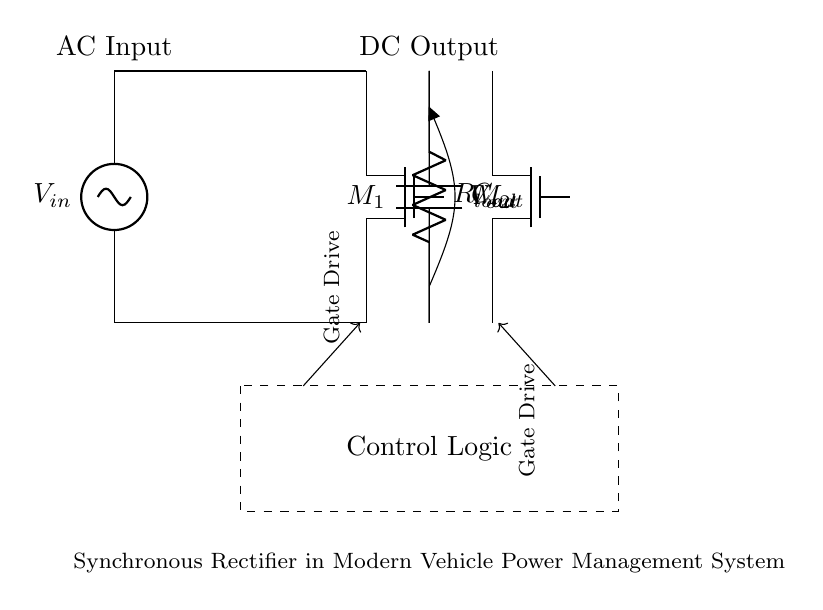What type of rectifier is shown in the circuit? The circuit employs synchronous rectification, which utilizes MOSFETs instead of diodes for converting AC to DC, enhancing efficiency.
Answer: Synchronous rectifier What is the function of the transformer in this circuit? The transformer steps down or steps up the AC voltage, providing either a higher or lower voltage as needed in the system.
Answer: Voltage transformation How many MOSFETs are used in this synchronous rectifier? There are two MOSFETs indicated in the circuit, denoted as M1 and M2, allowing for bi-directional current flow during the rectification process.
Answer: Two What does the output capacitor represent in this diagram? The output capacitor, labeled as C out, smoothens the output voltage by filtering out the fluctuations in the rectified DC signal.
Answer: Smoothing What is the purpose of the control logic block? The control logic block is responsible for managing the gate drive signals of the MOSFETs, ensuring they switch on and off at appropriate times for efficient rectification.
Answer: Manage MOSFET switching What component is labeled as R load? R load represents the load resistor connected to the output, indicating the load that the synchronous rectifier is powering with DC voltage.
Answer: Load resistor How does synchronous rectification improve efficiency compared to traditional methods? Synchronous rectification reduces voltage drop and power losses during conduction by using low-resistance MOSFETs instead of diodes, enhancing overall energy efficiency in the power management system.
Answer: Improved efficiency 